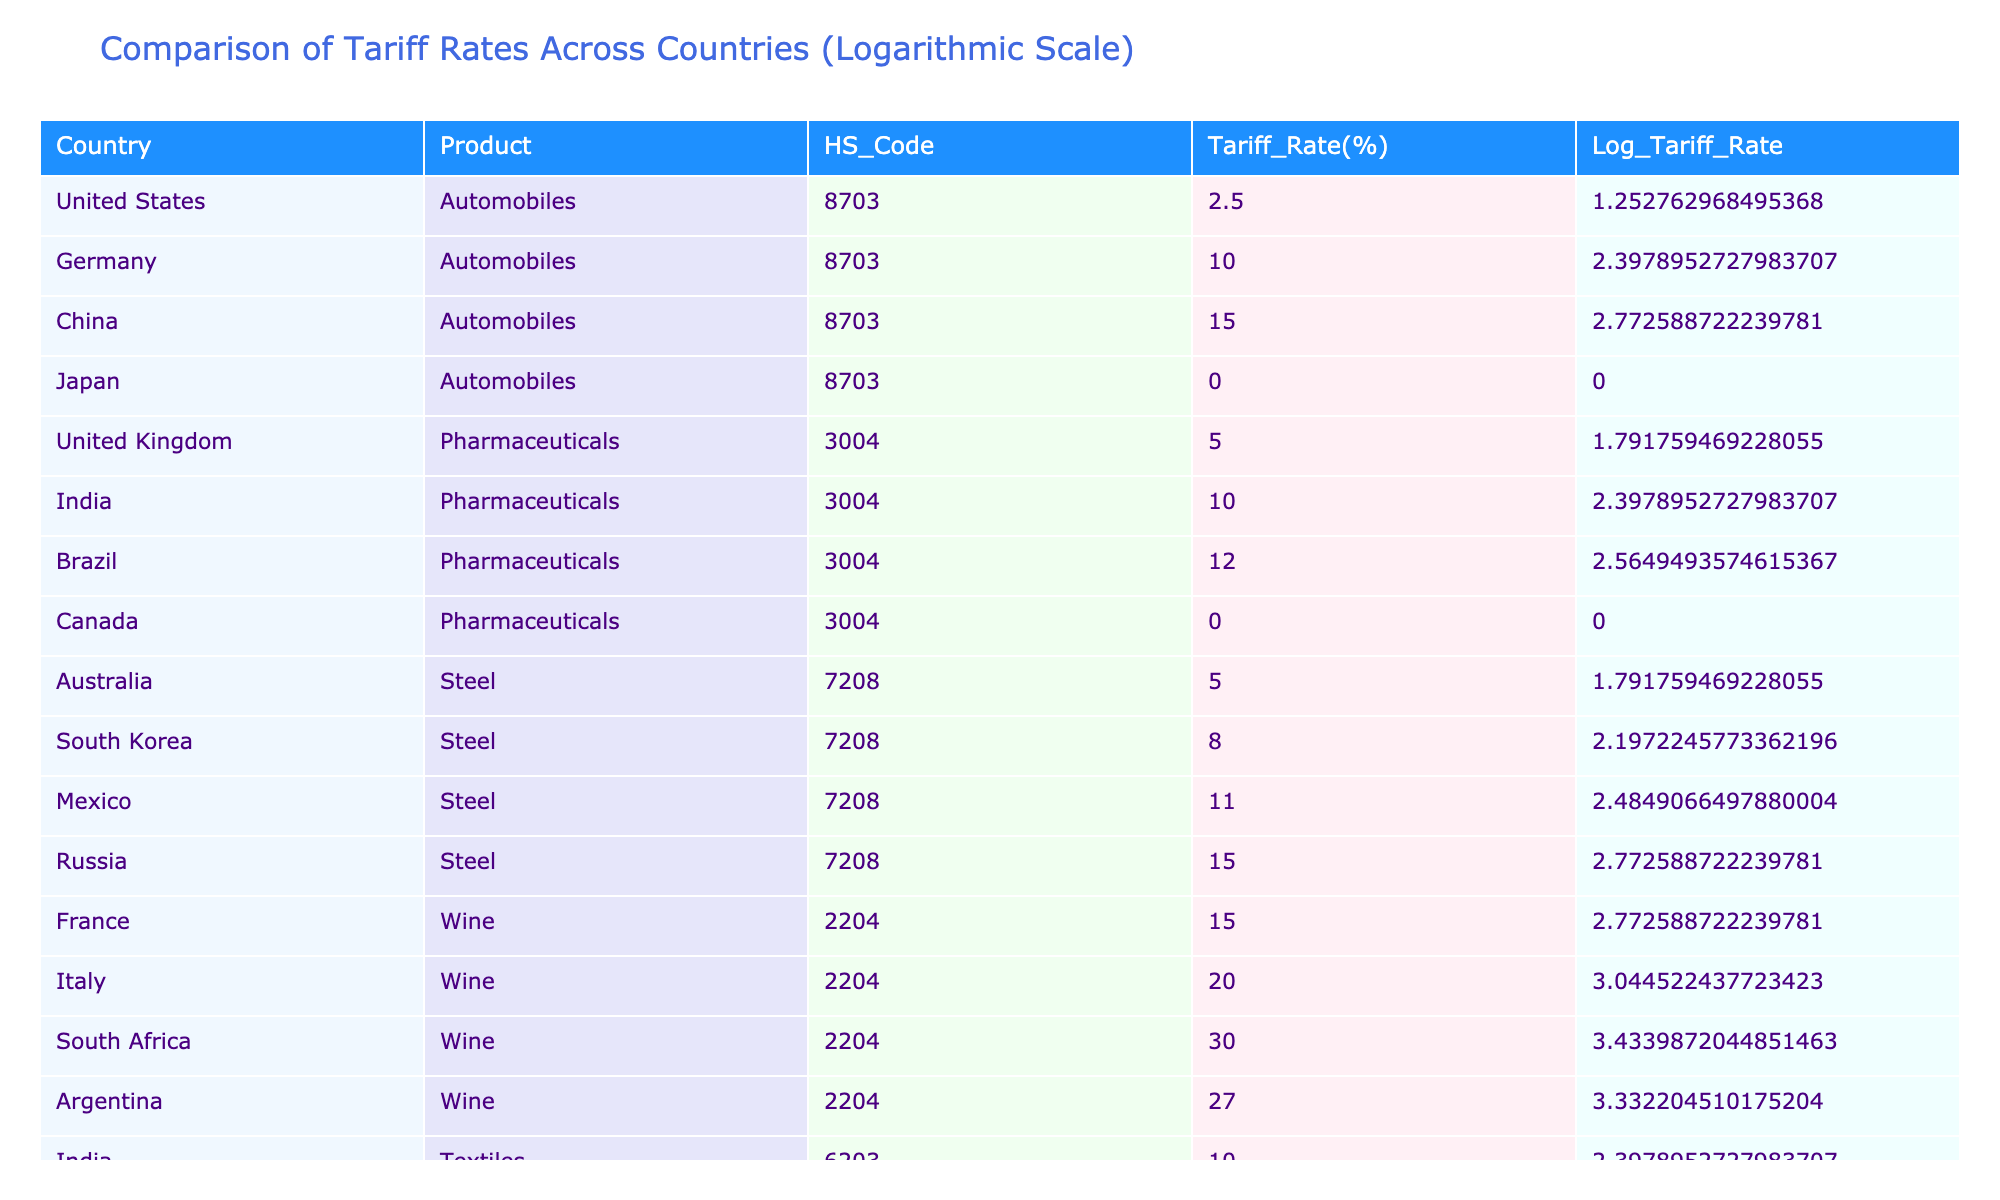What is the tariff rate for automobiles in Japan? The table shows the tariff rate for automobiles in Japan under the product "Automobiles" with HS Code "8703" listed as 0%.
Answer: 0% Which country has the highest tariff rate for steel? The table indicates that the highest tariff rate for steel, which is under the HS Code "7208", is 15% from Russia.
Answer: Russia What is the average tariff rate for pharmaceuticals across the given countries? The tariff rates for pharmaceuticals are as follows: US (5%), India (10%), Brazil (12%), Canada (0%). To calculate the average, sum these values: 5 + 10 + 12 + 0 = 27, then divide by the number of countries (4): 27/4 = 6.75%.
Answer: 6.75% Is the tariff rate for textiles higher in India compared to Bangladesh? According to the table, the tariff rate for textiles in India is 10%, while in Bangladesh it is 6%. Therefore, India's textile tariff rate is indeed higher than Bangladesh's.
Answer: Yes What is the difference in tariff rates for wine between Italy and South Africa? The tariff rate for wine in Italy is 20%, and in South Africa, it is 30%. The difference can be calculated as follows: 30 - 20 = 10%.
Answer: 10% Which country has a lower tariff rate for pharmaceuticals, Brazil or Canada? The table shows Brazil's tariff rate for pharmaceuticals is 12%, while Canada's is 0%. Therefore, Canada has a lower tariff rate compared to Brazil.
Answer: Canada What is the total tariff rate for automobiles across all the countries listed? The tariff rates for automobiles in the countries listed are: US (2.5%), Germany (10%), China (15%), and Japan (0%). To find the total, add these rates: 2.5 + 10 + 15 + 0 = 27.5%.
Answer: 27.5% Does any country have a 0% tariff rate for textiles? The table shows that Turkey has a tariff rate of 8%, and Bangladesh has 6%. Therefore, there is no country listed with a 0% tariff rate for textiles.
Answer: No 